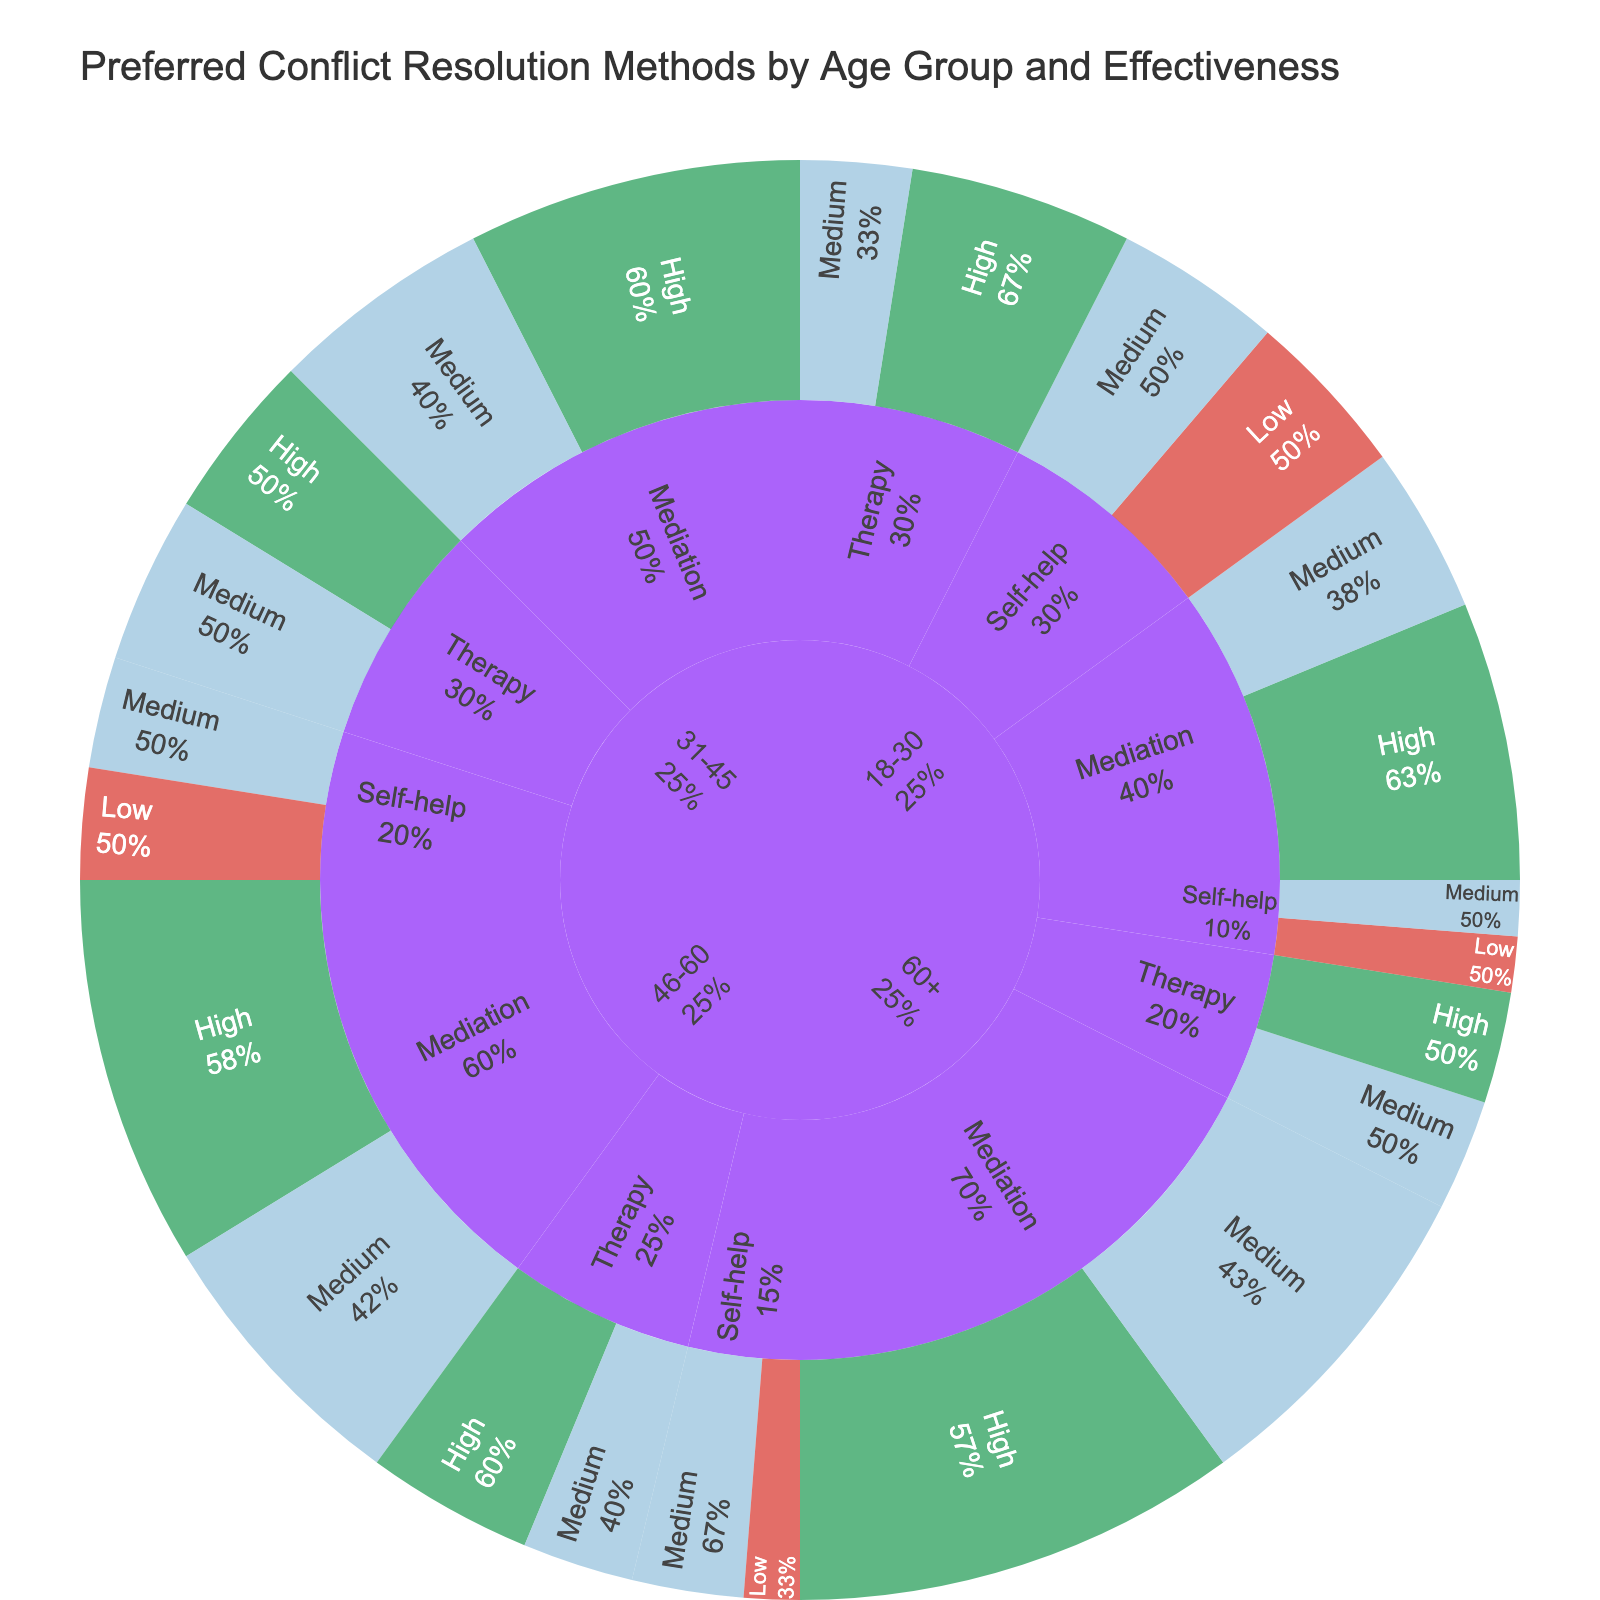What is the effectiveness rating with the highest percentage for the 18-30 age group? Look at the segments for the 18-30 age group in the sunburst plot. Find the segment with the label "High" and check its percentage.
Answer: High What is the most preferred conflict resolution method for the 31-45 age group based on high effectiveness? Find the 31-45 age group segment, then look for resolution methods under this category labeled with high effectiveness and compare their percentages.
Answer: Mediation What is the total percentage for the Mediation method across all age groups? Sum percentages of Mediation for all effectiveness ratings in each age group (25+15+30+20+35+25+40+30).
Answer: 220 How does the preference for Therapy in the 46-60 age group with high effectiveness compare to the 60+ age group? Look at the Therapy segments for both age groups. The 46-60 age group has Therapy labeled with high effectiveness at 15% while 60+ has it at 10%.
Answer: Higher Which effectiveness rating is least effective for the Self-help method in the 31-45 age group? Check the effectiveness ratings for Self-help in the 31-45 age group and look for the smallest percentage.
Answer: Low By how much does the high effectiveness of Mediation differ between the 18-30 age group and the 60+ age group? Find the high effectiveness Mediation percentage for both age groups, then subtract the percentage of the 18-30 age group from that of the 60+ age group (40-25).
Answer: 15 Which age group has the highest percentage for Medium effectiveness of Mediation? Compare the Medium effectiveness Mediation percentages across all age groups. The 60+ age group has 30% which is the highest.
Answer: 60+ What is the effectiveness rating with the lowest percentage for the 60+ age group? Look at all segments under the 60+ age group and find the segment with the lowest percentage.
Answer: Self-help, Low What is the total percentage for Therapy with medium effectiveness across all age groups? Sum the percentages for Therapy with medium effectiveness in each age group (10+15+10+10).
Answer: 45 Is Mediation more or less effective than Self-help for the 46-60 age group? Compare the combined percentages of high and medium effectiveness for Mediation and Self-help. Mediation is (35+25=60), Self-help is (10+5=15).
Answer: More 